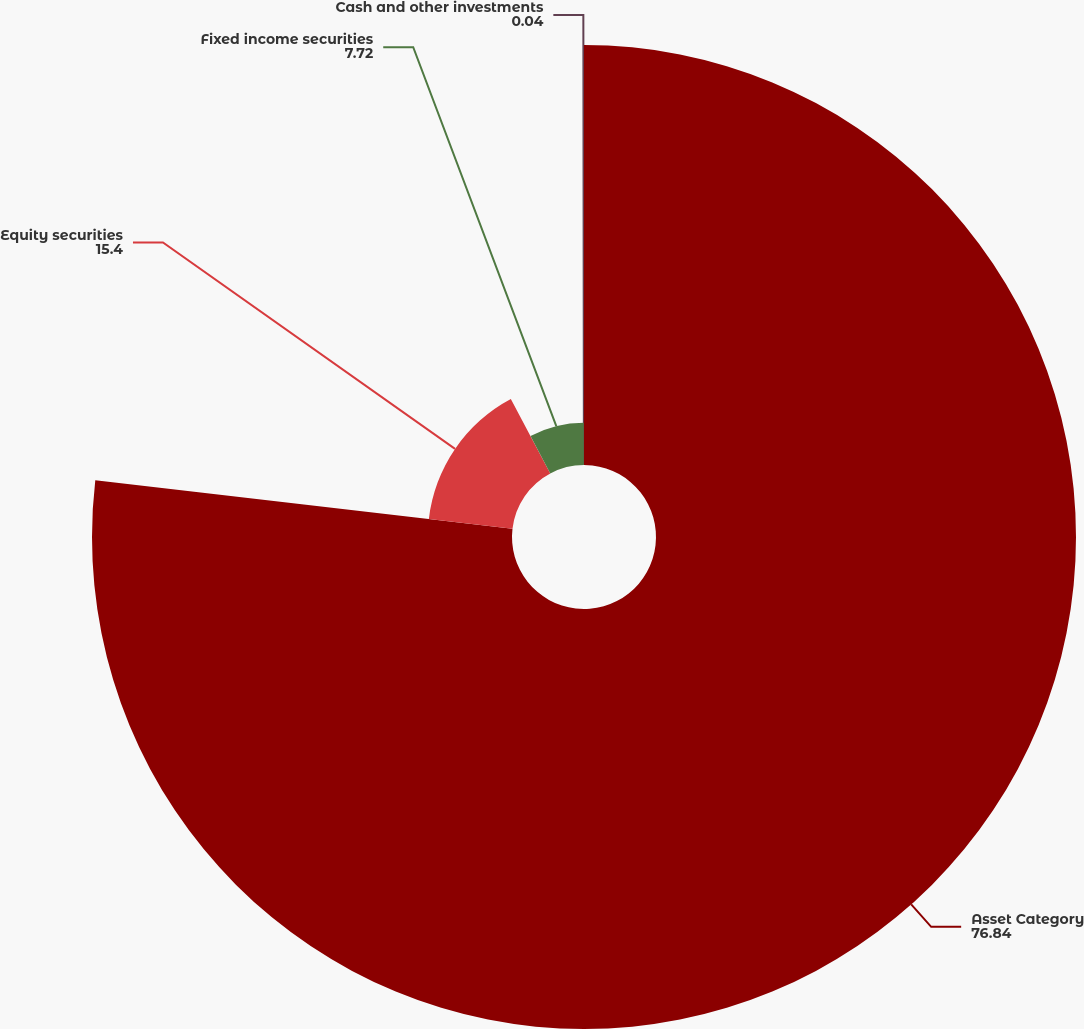Convert chart. <chart><loc_0><loc_0><loc_500><loc_500><pie_chart><fcel>Asset Category<fcel>Equity securities<fcel>Fixed income securities<fcel>Cash and other investments<nl><fcel>76.84%<fcel>15.4%<fcel>7.72%<fcel>0.04%<nl></chart> 